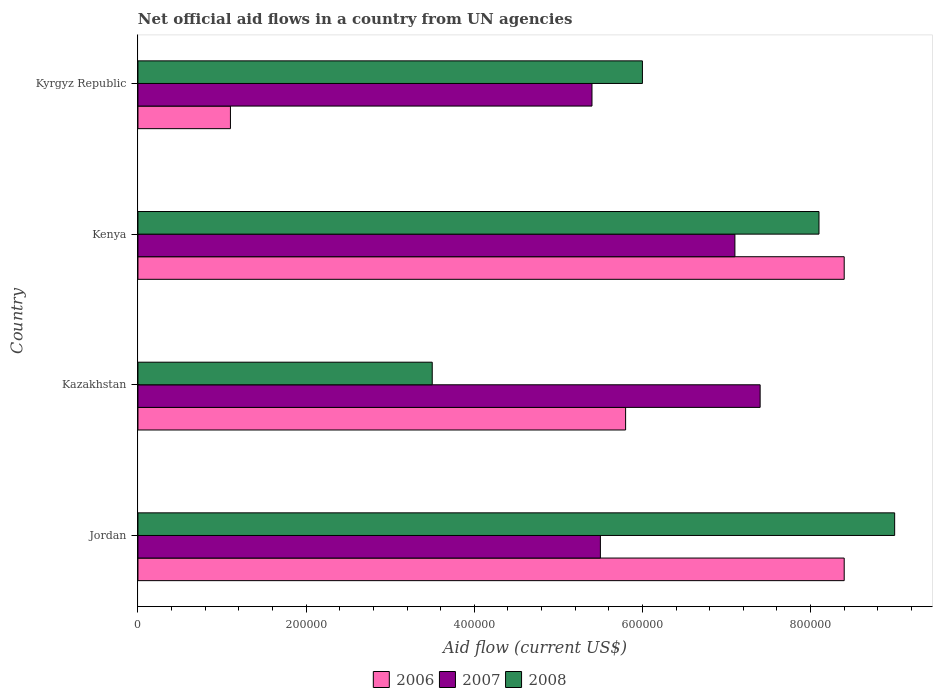How many different coloured bars are there?
Offer a very short reply. 3. How many bars are there on the 2nd tick from the top?
Make the answer very short. 3. How many bars are there on the 4th tick from the bottom?
Your response must be concise. 3. What is the label of the 1st group of bars from the top?
Give a very brief answer. Kyrgyz Republic. What is the net official aid flow in 2006 in Jordan?
Provide a succinct answer. 8.40e+05. Across all countries, what is the maximum net official aid flow in 2008?
Give a very brief answer. 9.00e+05. Across all countries, what is the minimum net official aid flow in 2007?
Your response must be concise. 5.40e+05. In which country was the net official aid flow in 2008 maximum?
Make the answer very short. Jordan. In which country was the net official aid flow in 2007 minimum?
Ensure brevity in your answer.  Kyrgyz Republic. What is the total net official aid flow in 2007 in the graph?
Offer a terse response. 2.54e+06. What is the difference between the net official aid flow in 2008 in Kazakhstan and that in Kenya?
Give a very brief answer. -4.60e+05. What is the difference between the net official aid flow in 2008 in Kazakhstan and the net official aid flow in 2006 in Kyrgyz Republic?
Provide a short and direct response. 2.40e+05. What is the average net official aid flow in 2006 per country?
Provide a short and direct response. 5.92e+05. What is the ratio of the net official aid flow in 2007 in Kazakhstan to that in Kenya?
Make the answer very short. 1.04. Is the net official aid flow in 2007 in Kazakhstan less than that in Kenya?
Offer a terse response. No. Is the difference between the net official aid flow in 2008 in Kazakhstan and Kenya greater than the difference between the net official aid flow in 2007 in Kazakhstan and Kenya?
Make the answer very short. No. What does the 2nd bar from the top in Kyrgyz Republic represents?
Your response must be concise. 2007. What does the 3rd bar from the bottom in Kyrgyz Republic represents?
Your answer should be very brief. 2008. Are the values on the major ticks of X-axis written in scientific E-notation?
Keep it short and to the point. No. Does the graph contain any zero values?
Offer a very short reply. No. Does the graph contain grids?
Offer a very short reply. No. How many legend labels are there?
Your answer should be compact. 3. How are the legend labels stacked?
Offer a very short reply. Horizontal. What is the title of the graph?
Your answer should be compact. Net official aid flows in a country from UN agencies. Does "2011" appear as one of the legend labels in the graph?
Provide a short and direct response. No. What is the label or title of the X-axis?
Provide a short and direct response. Aid flow (current US$). What is the Aid flow (current US$) of 2006 in Jordan?
Provide a short and direct response. 8.40e+05. What is the Aid flow (current US$) in 2007 in Jordan?
Make the answer very short. 5.50e+05. What is the Aid flow (current US$) in 2008 in Jordan?
Provide a succinct answer. 9.00e+05. What is the Aid flow (current US$) in 2006 in Kazakhstan?
Offer a terse response. 5.80e+05. What is the Aid flow (current US$) in 2007 in Kazakhstan?
Provide a short and direct response. 7.40e+05. What is the Aid flow (current US$) in 2006 in Kenya?
Provide a short and direct response. 8.40e+05. What is the Aid flow (current US$) of 2007 in Kenya?
Keep it short and to the point. 7.10e+05. What is the Aid flow (current US$) of 2008 in Kenya?
Keep it short and to the point. 8.10e+05. What is the Aid flow (current US$) of 2006 in Kyrgyz Republic?
Provide a short and direct response. 1.10e+05. What is the Aid flow (current US$) in 2007 in Kyrgyz Republic?
Provide a short and direct response. 5.40e+05. Across all countries, what is the maximum Aid flow (current US$) in 2006?
Provide a succinct answer. 8.40e+05. Across all countries, what is the maximum Aid flow (current US$) in 2007?
Offer a very short reply. 7.40e+05. Across all countries, what is the minimum Aid flow (current US$) of 2007?
Offer a very short reply. 5.40e+05. What is the total Aid flow (current US$) in 2006 in the graph?
Keep it short and to the point. 2.37e+06. What is the total Aid flow (current US$) of 2007 in the graph?
Provide a short and direct response. 2.54e+06. What is the total Aid flow (current US$) of 2008 in the graph?
Provide a short and direct response. 2.66e+06. What is the difference between the Aid flow (current US$) of 2006 in Jordan and that in Kazakhstan?
Your answer should be compact. 2.60e+05. What is the difference between the Aid flow (current US$) in 2007 in Jordan and that in Kazakhstan?
Your answer should be compact. -1.90e+05. What is the difference between the Aid flow (current US$) in 2008 in Jordan and that in Kazakhstan?
Offer a terse response. 5.50e+05. What is the difference between the Aid flow (current US$) in 2006 in Jordan and that in Kenya?
Make the answer very short. 0. What is the difference between the Aid flow (current US$) of 2008 in Jordan and that in Kenya?
Make the answer very short. 9.00e+04. What is the difference between the Aid flow (current US$) in 2006 in Jordan and that in Kyrgyz Republic?
Provide a short and direct response. 7.30e+05. What is the difference between the Aid flow (current US$) of 2008 in Jordan and that in Kyrgyz Republic?
Provide a short and direct response. 3.00e+05. What is the difference between the Aid flow (current US$) in 2007 in Kazakhstan and that in Kenya?
Your response must be concise. 3.00e+04. What is the difference between the Aid flow (current US$) in 2008 in Kazakhstan and that in Kenya?
Your answer should be very brief. -4.60e+05. What is the difference between the Aid flow (current US$) of 2006 in Kazakhstan and that in Kyrgyz Republic?
Give a very brief answer. 4.70e+05. What is the difference between the Aid flow (current US$) of 2007 in Kazakhstan and that in Kyrgyz Republic?
Keep it short and to the point. 2.00e+05. What is the difference between the Aid flow (current US$) in 2008 in Kazakhstan and that in Kyrgyz Republic?
Offer a very short reply. -2.50e+05. What is the difference between the Aid flow (current US$) in 2006 in Kenya and that in Kyrgyz Republic?
Offer a terse response. 7.30e+05. What is the difference between the Aid flow (current US$) of 2007 in Kenya and that in Kyrgyz Republic?
Offer a very short reply. 1.70e+05. What is the difference between the Aid flow (current US$) in 2006 in Jordan and the Aid flow (current US$) in 2007 in Kazakhstan?
Your response must be concise. 1.00e+05. What is the difference between the Aid flow (current US$) in 2006 in Jordan and the Aid flow (current US$) in 2008 in Kazakhstan?
Your answer should be compact. 4.90e+05. What is the difference between the Aid flow (current US$) of 2006 in Jordan and the Aid flow (current US$) of 2007 in Kenya?
Give a very brief answer. 1.30e+05. What is the difference between the Aid flow (current US$) in 2006 in Jordan and the Aid flow (current US$) in 2008 in Kenya?
Your answer should be compact. 3.00e+04. What is the difference between the Aid flow (current US$) in 2007 in Jordan and the Aid flow (current US$) in 2008 in Kenya?
Offer a very short reply. -2.60e+05. What is the difference between the Aid flow (current US$) in 2006 in Jordan and the Aid flow (current US$) in 2007 in Kyrgyz Republic?
Provide a succinct answer. 3.00e+05. What is the difference between the Aid flow (current US$) of 2007 in Jordan and the Aid flow (current US$) of 2008 in Kyrgyz Republic?
Offer a terse response. -5.00e+04. What is the difference between the Aid flow (current US$) of 2006 in Kazakhstan and the Aid flow (current US$) of 2008 in Kyrgyz Republic?
Your answer should be very brief. -2.00e+04. What is the difference between the Aid flow (current US$) in 2007 in Kazakhstan and the Aid flow (current US$) in 2008 in Kyrgyz Republic?
Keep it short and to the point. 1.40e+05. What is the difference between the Aid flow (current US$) of 2006 in Kenya and the Aid flow (current US$) of 2007 in Kyrgyz Republic?
Give a very brief answer. 3.00e+05. What is the average Aid flow (current US$) of 2006 per country?
Make the answer very short. 5.92e+05. What is the average Aid flow (current US$) of 2007 per country?
Your answer should be very brief. 6.35e+05. What is the average Aid flow (current US$) in 2008 per country?
Offer a very short reply. 6.65e+05. What is the difference between the Aid flow (current US$) of 2006 and Aid flow (current US$) of 2007 in Jordan?
Ensure brevity in your answer.  2.90e+05. What is the difference between the Aid flow (current US$) in 2006 and Aid flow (current US$) in 2008 in Jordan?
Your answer should be very brief. -6.00e+04. What is the difference between the Aid flow (current US$) in 2007 and Aid flow (current US$) in 2008 in Jordan?
Keep it short and to the point. -3.50e+05. What is the difference between the Aid flow (current US$) of 2006 and Aid flow (current US$) of 2007 in Kazakhstan?
Provide a succinct answer. -1.60e+05. What is the difference between the Aid flow (current US$) in 2006 and Aid flow (current US$) in 2008 in Kazakhstan?
Provide a short and direct response. 2.30e+05. What is the difference between the Aid flow (current US$) of 2007 and Aid flow (current US$) of 2008 in Kazakhstan?
Give a very brief answer. 3.90e+05. What is the difference between the Aid flow (current US$) in 2006 and Aid flow (current US$) in 2007 in Kenya?
Keep it short and to the point. 1.30e+05. What is the difference between the Aid flow (current US$) in 2006 and Aid flow (current US$) in 2007 in Kyrgyz Republic?
Provide a short and direct response. -4.30e+05. What is the difference between the Aid flow (current US$) in 2006 and Aid flow (current US$) in 2008 in Kyrgyz Republic?
Provide a succinct answer. -4.90e+05. What is the ratio of the Aid flow (current US$) in 2006 in Jordan to that in Kazakhstan?
Provide a short and direct response. 1.45. What is the ratio of the Aid flow (current US$) of 2007 in Jordan to that in Kazakhstan?
Offer a very short reply. 0.74. What is the ratio of the Aid flow (current US$) in 2008 in Jordan to that in Kazakhstan?
Your response must be concise. 2.57. What is the ratio of the Aid flow (current US$) of 2007 in Jordan to that in Kenya?
Offer a very short reply. 0.77. What is the ratio of the Aid flow (current US$) in 2006 in Jordan to that in Kyrgyz Republic?
Offer a very short reply. 7.64. What is the ratio of the Aid flow (current US$) of 2007 in Jordan to that in Kyrgyz Republic?
Offer a very short reply. 1.02. What is the ratio of the Aid flow (current US$) of 2006 in Kazakhstan to that in Kenya?
Provide a succinct answer. 0.69. What is the ratio of the Aid flow (current US$) of 2007 in Kazakhstan to that in Kenya?
Your answer should be very brief. 1.04. What is the ratio of the Aid flow (current US$) in 2008 in Kazakhstan to that in Kenya?
Offer a terse response. 0.43. What is the ratio of the Aid flow (current US$) in 2006 in Kazakhstan to that in Kyrgyz Republic?
Your answer should be compact. 5.27. What is the ratio of the Aid flow (current US$) in 2007 in Kazakhstan to that in Kyrgyz Republic?
Give a very brief answer. 1.37. What is the ratio of the Aid flow (current US$) of 2008 in Kazakhstan to that in Kyrgyz Republic?
Your response must be concise. 0.58. What is the ratio of the Aid flow (current US$) of 2006 in Kenya to that in Kyrgyz Republic?
Offer a terse response. 7.64. What is the ratio of the Aid flow (current US$) of 2007 in Kenya to that in Kyrgyz Republic?
Offer a terse response. 1.31. What is the ratio of the Aid flow (current US$) in 2008 in Kenya to that in Kyrgyz Republic?
Offer a terse response. 1.35. What is the difference between the highest and the second highest Aid flow (current US$) in 2006?
Provide a short and direct response. 0. What is the difference between the highest and the second highest Aid flow (current US$) of 2007?
Give a very brief answer. 3.00e+04. What is the difference between the highest and the second highest Aid flow (current US$) of 2008?
Ensure brevity in your answer.  9.00e+04. What is the difference between the highest and the lowest Aid flow (current US$) of 2006?
Your answer should be very brief. 7.30e+05. What is the difference between the highest and the lowest Aid flow (current US$) of 2007?
Offer a terse response. 2.00e+05. 